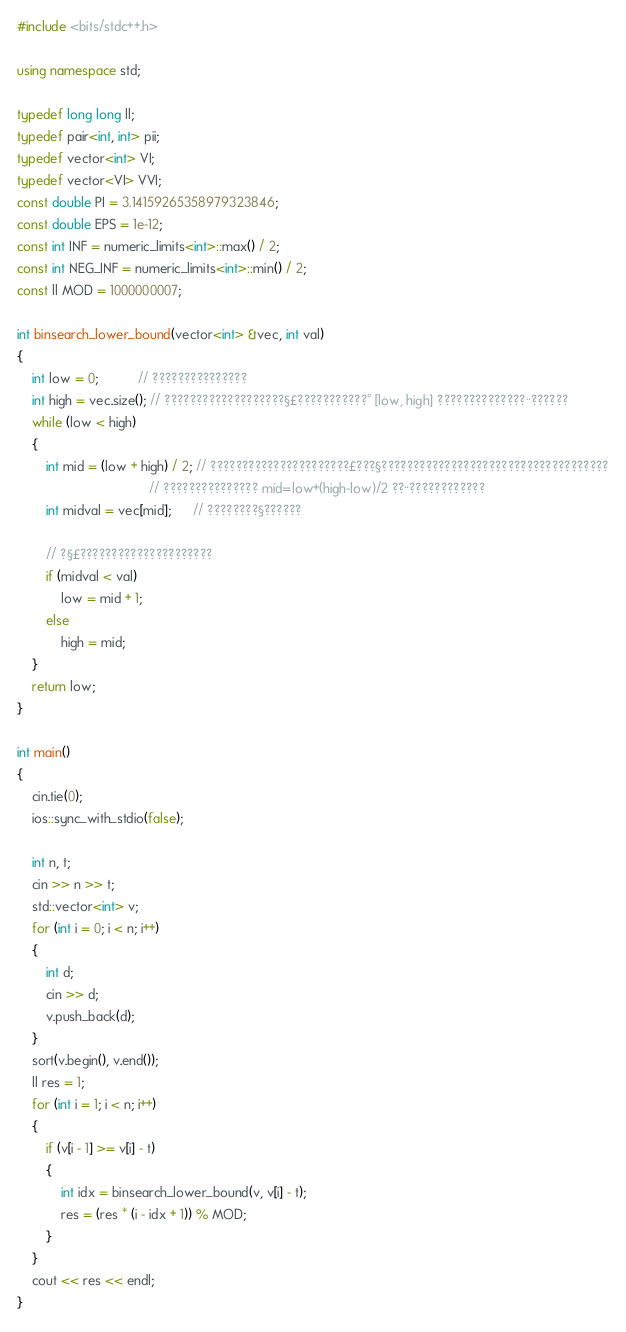Convert code to text. <code><loc_0><loc_0><loc_500><loc_500><_C++_>#include <bits/stdc++.h>

using namespace std;

typedef long long ll;
typedef pair<int, int> pii;
typedef vector<int> VI;
typedef vector<VI> VVI;
const double PI = 3.14159265358979323846;
const double EPS = 1e-12;
const int INF = numeric_limits<int>::max() / 2;
const int NEG_INF = numeric_limits<int>::min() / 2;
const ll MOD = 1000000007;

int binsearch_lower_bound(vector<int> &vec, int val)
{
    int low = 0;           // ???????????????
    int high = vec.size(); // ???????????????????§£???????????° [low, high] ??????????????¨??????
    while (low < high)
    {
        int mid = (low + high) / 2; // ??????????????????????£???§????????????????????????????????????
                                    // ??????????????? mid=low+(high-low)/2 ??¨????????????
        int midval = vec[mid];      // ????????§??????

        // ?§£?????????????????????
        if (midval < val)
            low = mid + 1;
        else
            high = mid;
    }
    return low;
}

int main()
{
    cin.tie(0);
    ios::sync_with_stdio(false);

    int n, t;
    cin >> n >> t;
    std::vector<int> v;
    for (int i = 0; i < n; i++)
    {
        int d;
        cin >> d;
        v.push_back(d);
    }
    sort(v.begin(), v.end());
    ll res = 1;
    for (int i = 1; i < n; i++)
    {
        if (v[i - 1] >= v[i] - t)
        {
            int idx = binsearch_lower_bound(v, v[i] - t);
            res = (res * (i - idx + 1)) % MOD;
        }
    }
    cout << res << endl;
}
</code> 